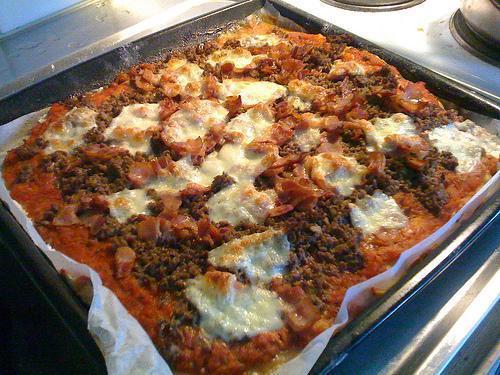How many pans of food are there?
Give a very brief answer. 1. How many people are eating food?
Give a very brief answer. 0. 